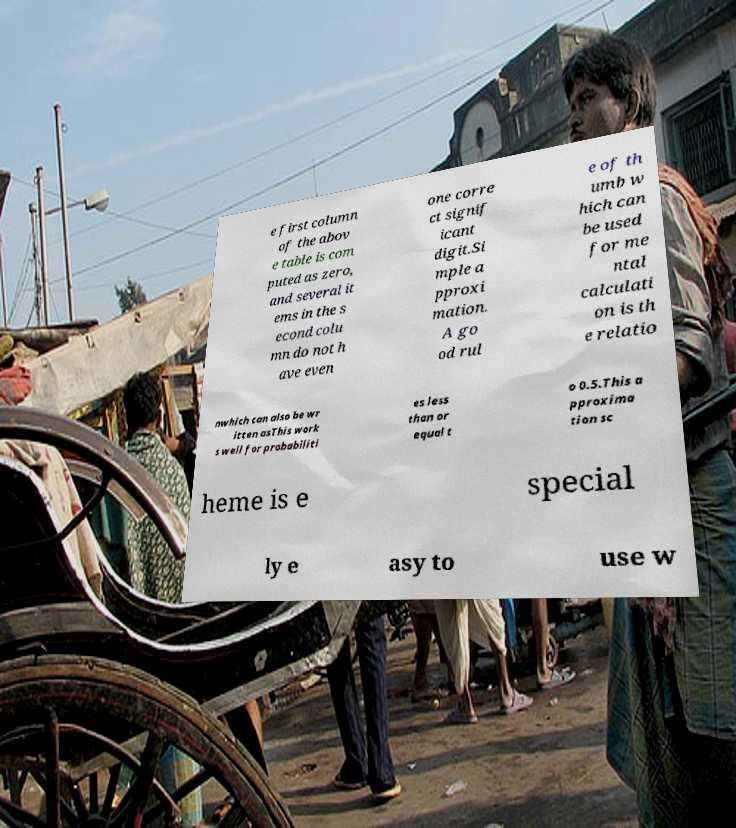For documentation purposes, I need the text within this image transcribed. Could you provide that? e first column of the abov e table is com puted as zero, and several it ems in the s econd colu mn do not h ave even one corre ct signif icant digit.Si mple a pproxi mation. A go od rul e of th umb w hich can be used for me ntal calculati on is th e relatio nwhich can also be wr itten asThis work s well for probabiliti es less than or equal t o 0.5.This a pproxima tion sc heme is e special ly e asy to use w 